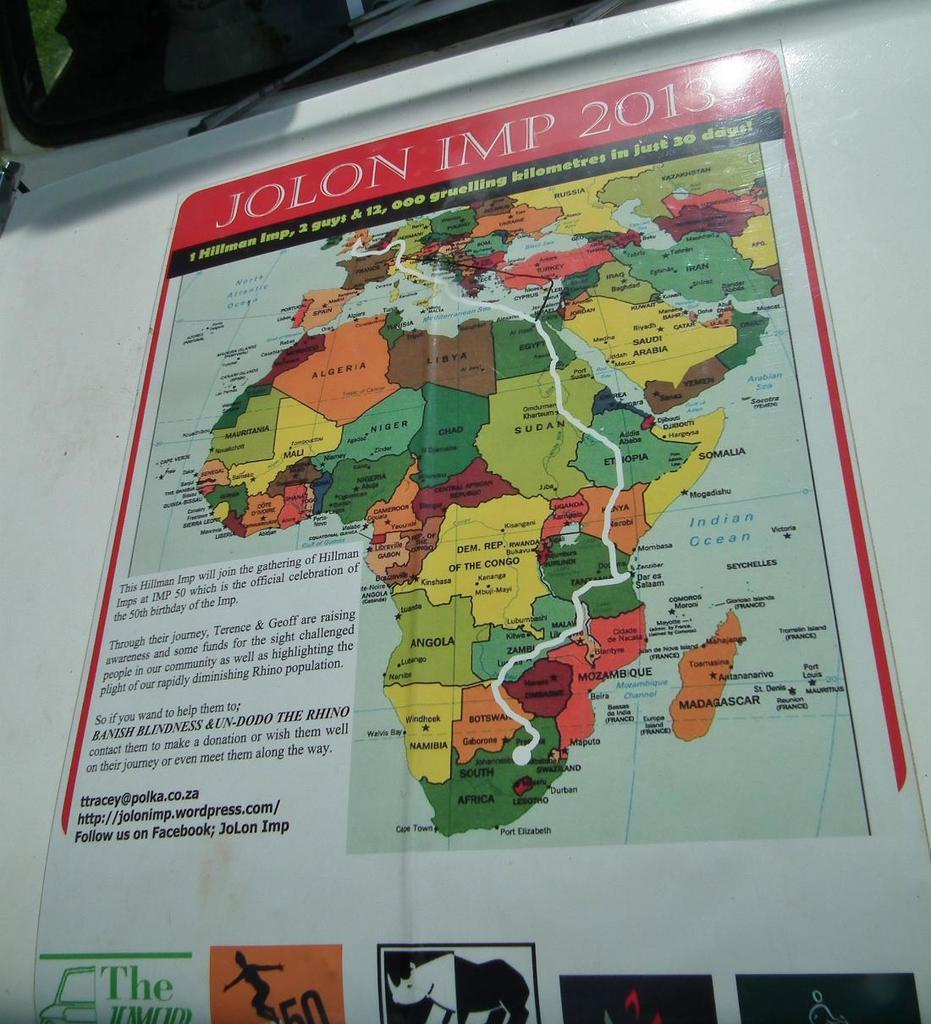<image>
Create a compact narrative representing the image presented. A map has the word Jolon IMP 2013 written at the top. 